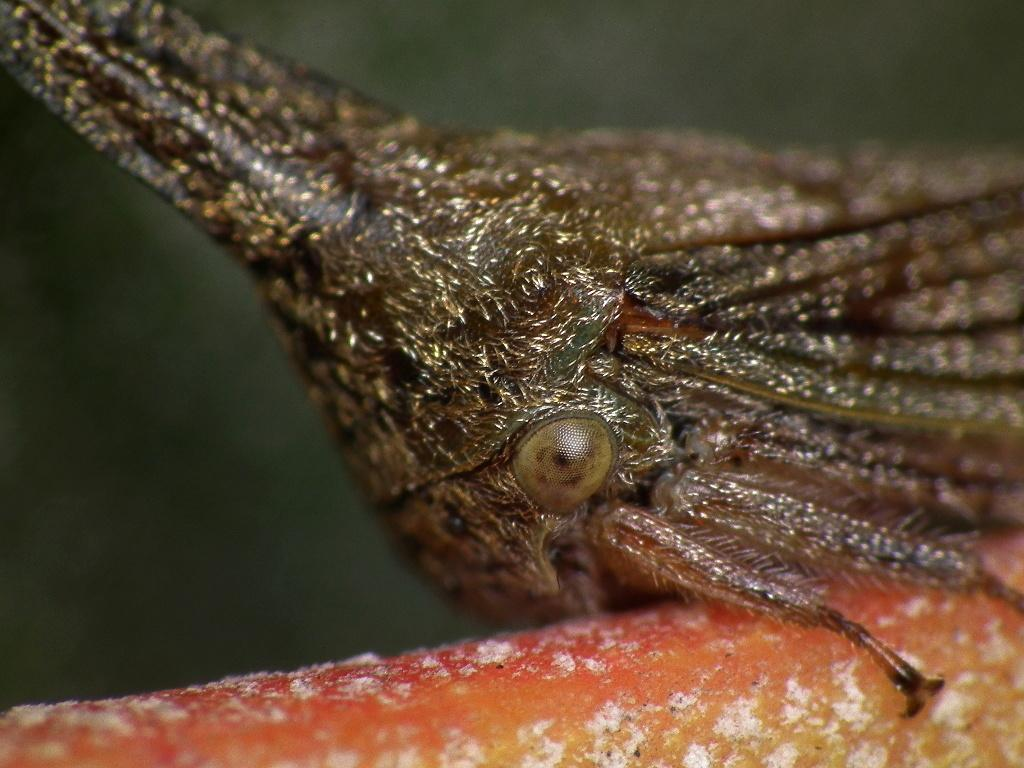What type of creature can be seen in the image? There is an insect in the image. What is the insect doing or resting on in the image? The insect is on some object in the image. What type of angle is the farmer using to fix the leg of the table in the image? There is no farmer or table with a leg present in the image; it only features an insect on an object. 